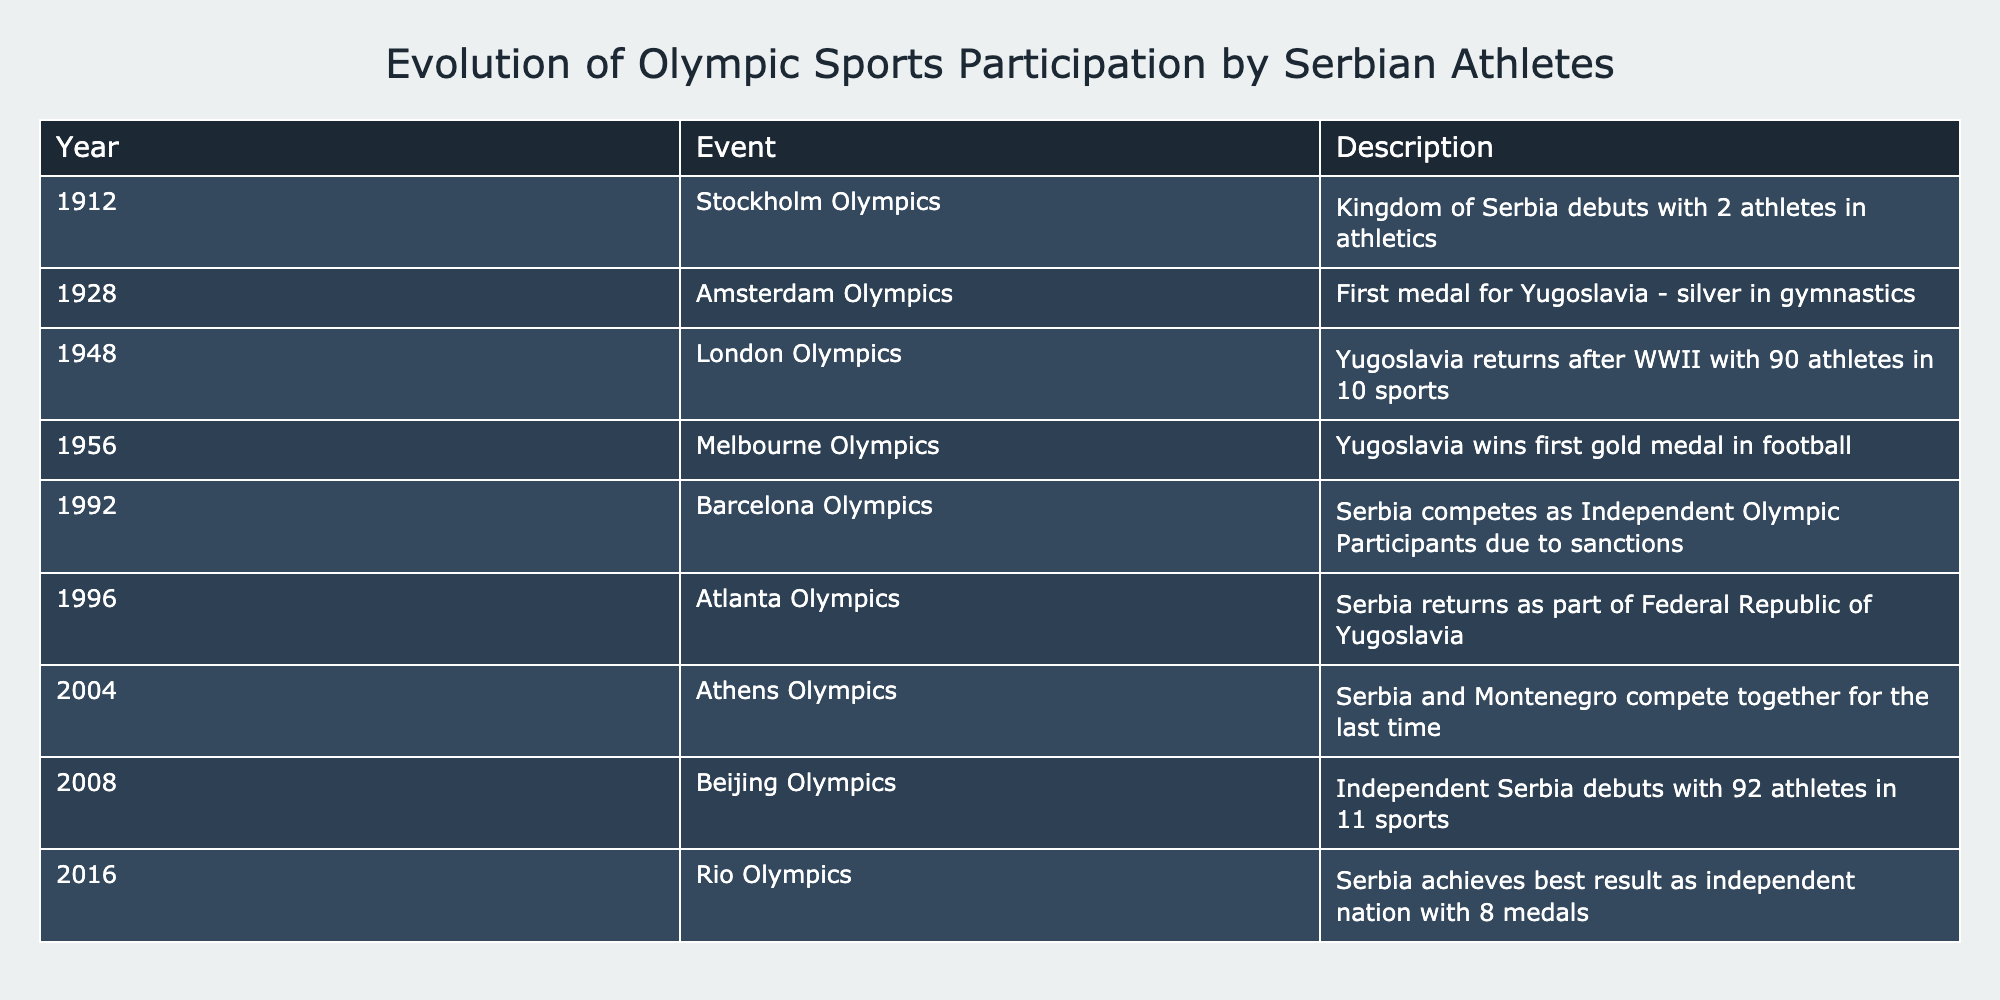What year did Serbia debut in the Olympics? The table shows that Serbia debuted at the Stockholm Olympics in 1912.
Answer: 1912 How many athletes represented Yugoslavia in the 1948 London Olympics? According to the table, Yugoslavia had 90 athletes participating in 10 different sports in the 1948 Olympics.
Answer: 90 Did Serbia win any gold medals in the 1956 Melbourne Olympics? The table confirms that Yugoslavia won its first gold medal in football during the 1956 Olympics.
Answer: Yes What was the total number of medals Serbia achieved in the 2016 Rio Olympics? The table states that Serbia achieved its best result as an independent nation with a total of 8 medals in the 2016 Olympics.
Answer: 8 In which Olympic event did Serbia first compete as an independent nation? The table reveals that Serbia debuted independently at the Beijing Olympics in 2008.
Answer: Beijing Olympics How many more athletes participated in the 2008 Beijing Olympics compared to the 1912 Stockholm Olympics? In 2008, 92 athletes participated, while in 1912, there were only 2 athletes. Therefore, the difference is 92 - 2 = 90 athletes.
Answer: 90 Was there an Olympic appearance of Serbia in the 1996 Atlanta Olympics under the same name? The table indicates that Serbia competed under the name "Federal Republic of Yugoslavia" in the 1996 Atlanta Olympics.
Answer: No What was the progression of the number of athletes from the 1948 London Olympics to the 2004 Athens Olympics? In 1948, there were 90 athletes, and by 2004, there is no specified number in the table, but since the 2004 Olympics were listed under Serbia and Montenegro, the assumption is that there was a continuous participation. Details about the specific number of athletes are not provided for 2004 in the table.
Answer: Unknown 